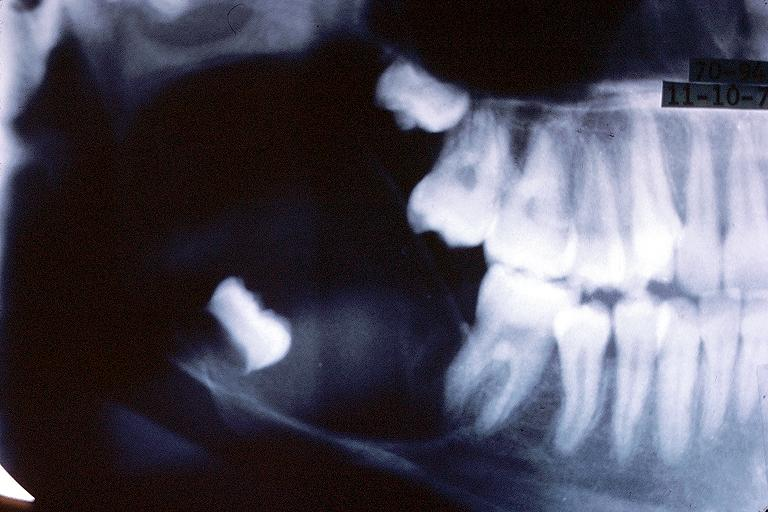does this image show unicystic ameloblastom?
Answer the question using a single word or phrase. Yes 